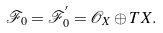<formula> <loc_0><loc_0><loc_500><loc_500>\mathcal { F } _ { 0 } = \mathcal { F } ^ { ^ { \prime } } _ { 0 } = \mathcal { O } _ { X } \oplus T X .</formula> 